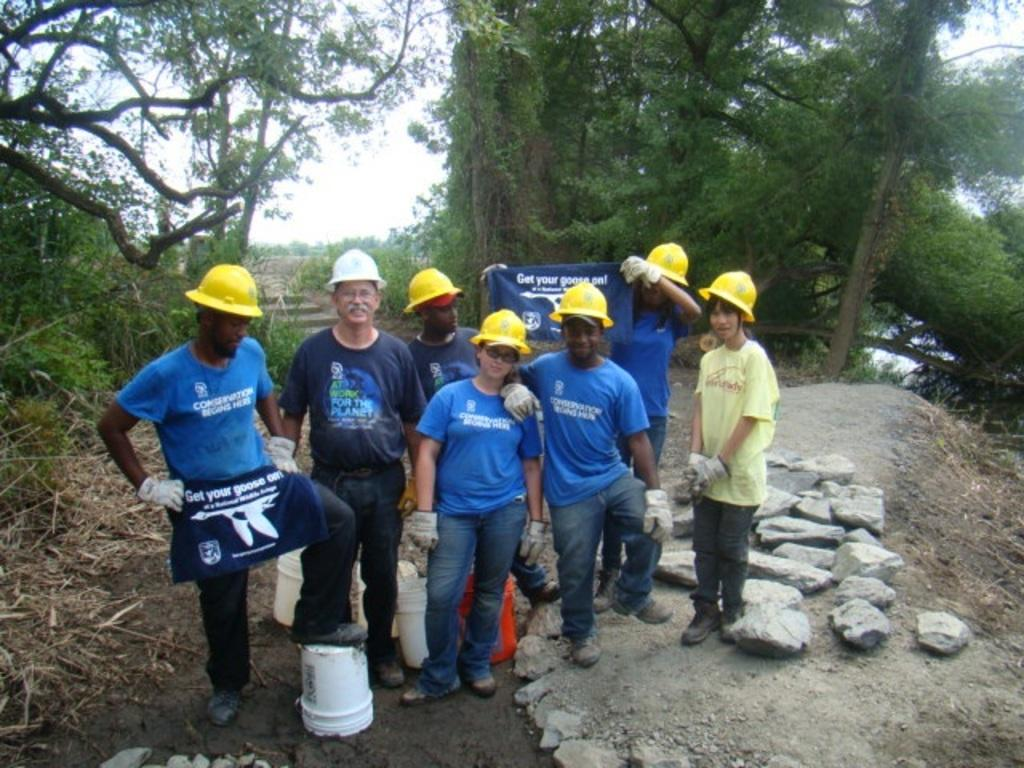<image>
Share a concise interpretation of the image provided. A man wearing an apron that says get your goose on has his foot up on a bucket. 